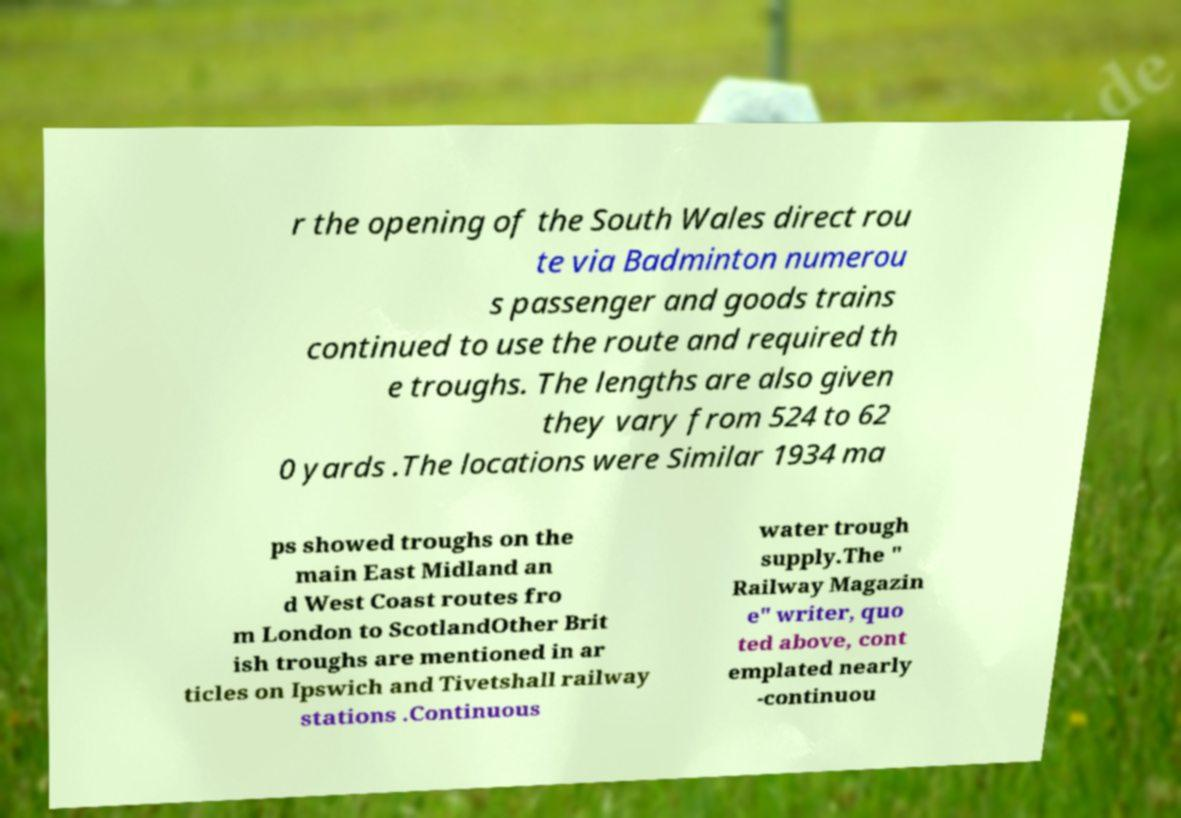Can you read and provide the text displayed in the image?This photo seems to have some interesting text. Can you extract and type it out for me? r the opening of the South Wales direct rou te via Badminton numerou s passenger and goods trains continued to use the route and required th e troughs. The lengths are also given they vary from 524 to 62 0 yards .The locations were Similar 1934 ma ps showed troughs on the main East Midland an d West Coast routes fro m London to ScotlandOther Brit ish troughs are mentioned in ar ticles on Ipswich and Tivetshall railway stations .Continuous water trough supply.The " Railway Magazin e" writer, quo ted above, cont emplated nearly -continuou 